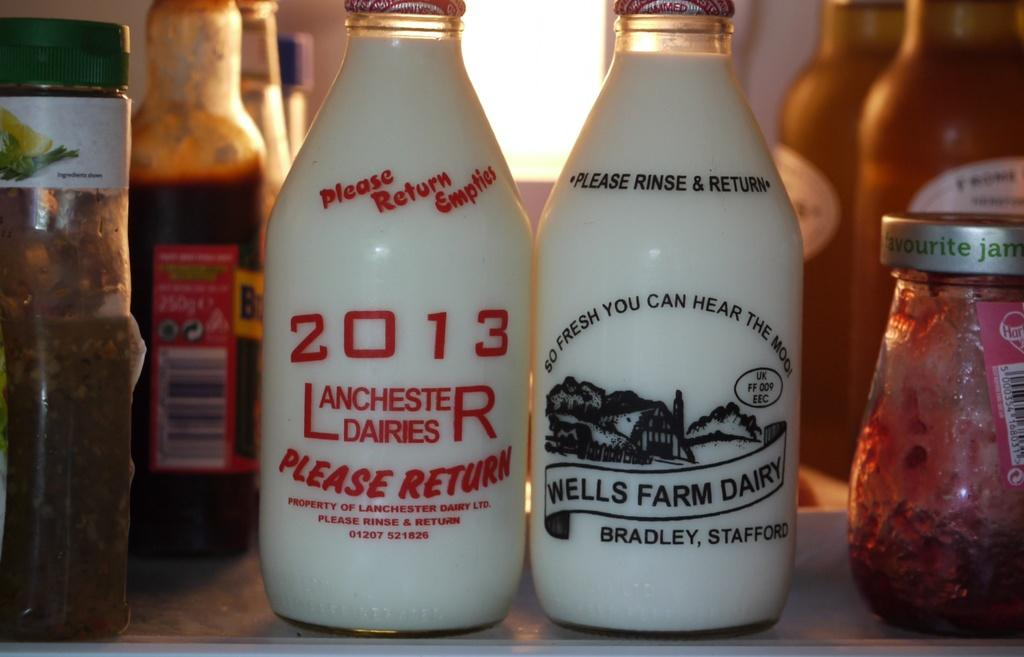Provide a one-sentence caption for the provided image. Two glasses of milk sit next to each other, one from wells farm dairy. 